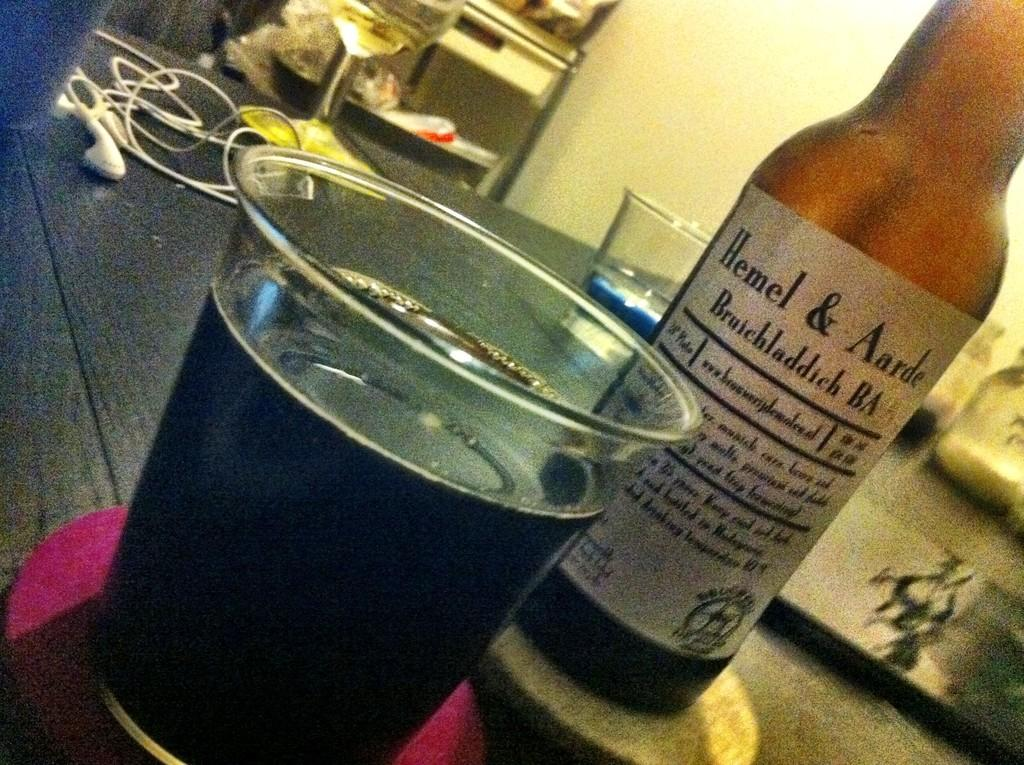Provide a one-sentence caption for the provided image. Bottle of Hemel & Aarde with a cup full beside it. 